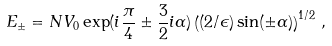<formula> <loc_0><loc_0><loc_500><loc_500>E _ { \pm } = N V _ { 0 } \exp ( i \frac { \pi } { 4 } \pm \frac { 3 } { 2 } i \alpha ) \left ( ( 2 / \epsilon ) \sin ( \pm \alpha ) \right ) ^ { 1 / 2 } \, ,</formula> 